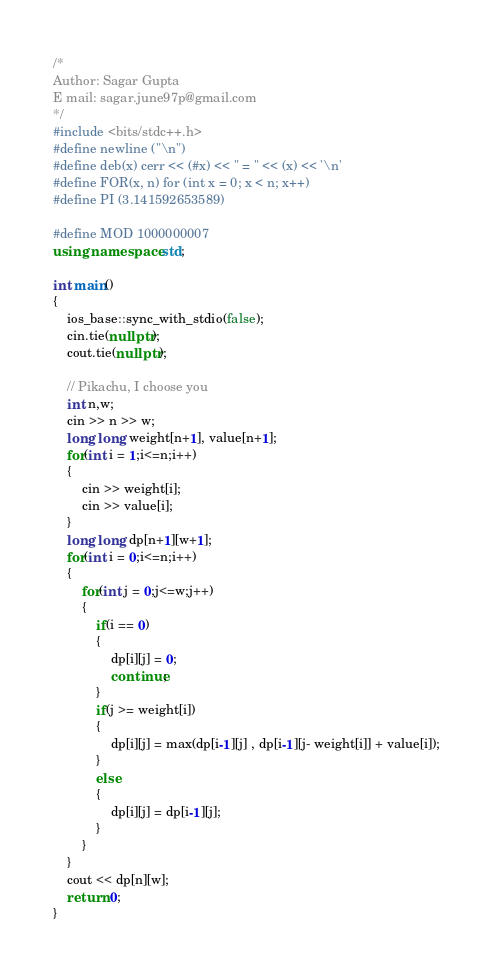<code> <loc_0><loc_0><loc_500><loc_500><_C++_>/*
Author: Sagar Gupta
E mail: sagar.june97p@gmail.com
*/
#include <bits/stdc++.h>
#define newline ("\n")
#define deb(x) cerr << (#x) << " = " << (x) << '\n'
#define FOR(x, n) for (int x = 0; x < n; x++)
#define PI (3.141592653589)

#define MOD 1000000007
using namespace std;

int main()
{
    ios_base::sync_with_stdio(false);
    cin.tie(nullptr);
    cout.tie(nullptr);

    // Pikachu, I choose you
    int n,w;
    cin >> n >> w;
    long long weight[n+1], value[n+1];
    for(int i = 1;i<=n;i++)
    {
        cin >> weight[i];
        cin >> value[i];
    }
    long long dp[n+1][w+1];
    for(int i = 0;i<=n;i++)
    {
        for(int j = 0;j<=w;j++)
        {
            if(i == 0)
            {
                dp[i][j] = 0;
                continue;
            }
            if(j >= weight[i])
            {
                dp[i][j] = max(dp[i-1][j] , dp[i-1][j- weight[i]] + value[i]);
            }
            else
            {
                dp[i][j] = dp[i-1][j];
            }
        }
    }
    cout << dp[n][w];
    return 0;
}
</code> 